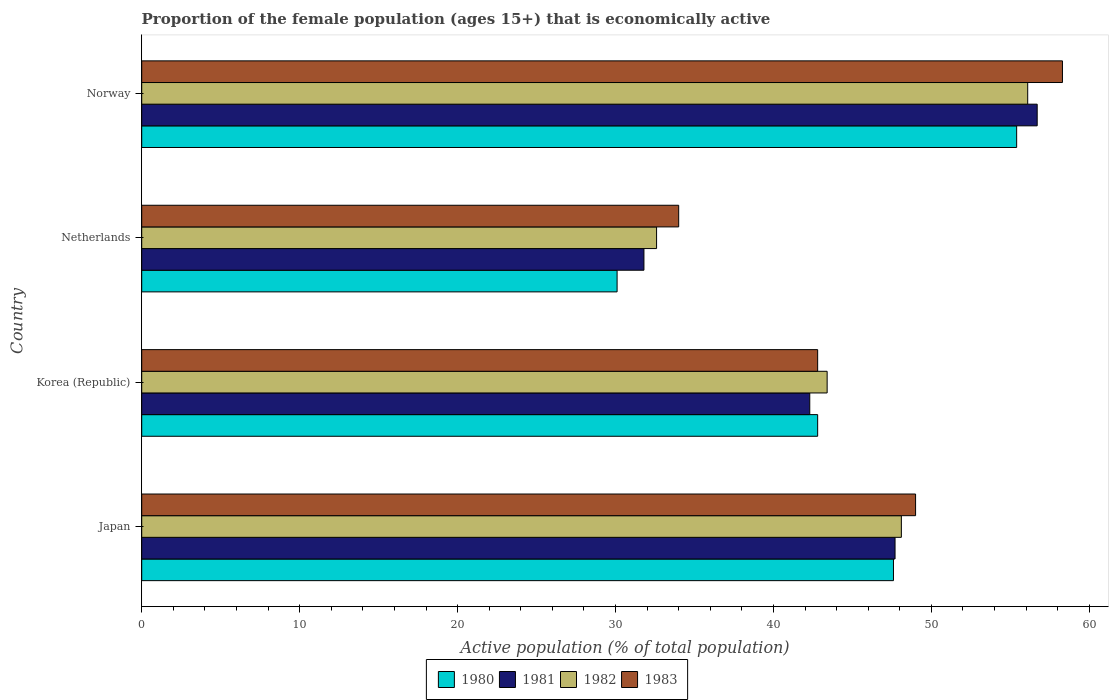How many groups of bars are there?
Provide a short and direct response. 4. How many bars are there on the 3rd tick from the bottom?
Your answer should be compact. 4. What is the label of the 4th group of bars from the top?
Your answer should be very brief. Japan. In how many cases, is the number of bars for a given country not equal to the number of legend labels?
Give a very brief answer. 0. What is the proportion of the female population that is economically active in 1983 in Korea (Republic)?
Your answer should be compact. 42.8. Across all countries, what is the maximum proportion of the female population that is economically active in 1982?
Your response must be concise. 56.1. Across all countries, what is the minimum proportion of the female population that is economically active in 1983?
Provide a succinct answer. 34. In which country was the proportion of the female population that is economically active in 1982 maximum?
Make the answer very short. Norway. What is the total proportion of the female population that is economically active in 1982 in the graph?
Your response must be concise. 180.2. What is the difference between the proportion of the female population that is economically active in 1982 in Netherlands and that in Norway?
Give a very brief answer. -23.5. What is the difference between the proportion of the female population that is economically active in 1982 in Korea (Republic) and the proportion of the female population that is economically active in 1981 in Netherlands?
Ensure brevity in your answer.  11.6. What is the average proportion of the female population that is economically active in 1980 per country?
Offer a terse response. 43.97. What is the difference between the proportion of the female population that is economically active in 1983 and proportion of the female population that is economically active in 1981 in Japan?
Give a very brief answer. 1.3. In how many countries, is the proportion of the female population that is economically active in 1983 greater than 22 %?
Your response must be concise. 4. What is the ratio of the proportion of the female population that is economically active in 1981 in Japan to that in Korea (Republic)?
Your answer should be compact. 1.13. Is the proportion of the female population that is economically active in 1983 in Netherlands less than that in Norway?
Provide a short and direct response. Yes. Is the difference between the proportion of the female population that is economically active in 1983 in Japan and Norway greater than the difference between the proportion of the female population that is economically active in 1981 in Japan and Norway?
Your answer should be very brief. No. What is the difference between the highest and the lowest proportion of the female population that is economically active in 1980?
Provide a succinct answer. 25.3. What does the 1st bar from the top in Norway represents?
Your response must be concise. 1983. What does the 4th bar from the bottom in Japan represents?
Your answer should be very brief. 1983. Is it the case that in every country, the sum of the proportion of the female population that is economically active in 1983 and proportion of the female population that is economically active in 1980 is greater than the proportion of the female population that is economically active in 1981?
Give a very brief answer. Yes. How many bars are there?
Offer a very short reply. 16. Are all the bars in the graph horizontal?
Provide a succinct answer. Yes. What is the difference between two consecutive major ticks on the X-axis?
Offer a very short reply. 10. Does the graph contain any zero values?
Give a very brief answer. No. Does the graph contain grids?
Provide a succinct answer. No. How many legend labels are there?
Offer a terse response. 4. How are the legend labels stacked?
Make the answer very short. Horizontal. What is the title of the graph?
Give a very brief answer. Proportion of the female population (ages 15+) that is economically active. Does "1979" appear as one of the legend labels in the graph?
Your answer should be very brief. No. What is the label or title of the X-axis?
Offer a terse response. Active population (% of total population). What is the Active population (% of total population) of 1980 in Japan?
Keep it short and to the point. 47.6. What is the Active population (% of total population) of 1981 in Japan?
Your answer should be very brief. 47.7. What is the Active population (% of total population) in 1982 in Japan?
Give a very brief answer. 48.1. What is the Active population (% of total population) of 1980 in Korea (Republic)?
Your answer should be very brief. 42.8. What is the Active population (% of total population) of 1981 in Korea (Republic)?
Offer a very short reply. 42.3. What is the Active population (% of total population) of 1982 in Korea (Republic)?
Keep it short and to the point. 43.4. What is the Active population (% of total population) of 1983 in Korea (Republic)?
Your answer should be compact. 42.8. What is the Active population (% of total population) in 1980 in Netherlands?
Keep it short and to the point. 30.1. What is the Active population (% of total population) in 1981 in Netherlands?
Keep it short and to the point. 31.8. What is the Active population (% of total population) in 1982 in Netherlands?
Offer a very short reply. 32.6. What is the Active population (% of total population) in 1983 in Netherlands?
Offer a terse response. 34. What is the Active population (% of total population) in 1980 in Norway?
Your answer should be very brief. 55.4. What is the Active population (% of total population) of 1981 in Norway?
Your response must be concise. 56.7. What is the Active population (% of total population) of 1982 in Norway?
Provide a short and direct response. 56.1. What is the Active population (% of total population) of 1983 in Norway?
Provide a short and direct response. 58.3. Across all countries, what is the maximum Active population (% of total population) in 1980?
Provide a short and direct response. 55.4. Across all countries, what is the maximum Active population (% of total population) of 1981?
Your answer should be very brief. 56.7. Across all countries, what is the maximum Active population (% of total population) in 1982?
Ensure brevity in your answer.  56.1. Across all countries, what is the maximum Active population (% of total population) of 1983?
Give a very brief answer. 58.3. Across all countries, what is the minimum Active population (% of total population) in 1980?
Offer a terse response. 30.1. Across all countries, what is the minimum Active population (% of total population) of 1981?
Your answer should be very brief. 31.8. Across all countries, what is the minimum Active population (% of total population) of 1982?
Keep it short and to the point. 32.6. What is the total Active population (% of total population) of 1980 in the graph?
Offer a very short reply. 175.9. What is the total Active population (% of total population) of 1981 in the graph?
Offer a very short reply. 178.5. What is the total Active population (% of total population) of 1982 in the graph?
Offer a terse response. 180.2. What is the total Active population (% of total population) of 1983 in the graph?
Provide a short and direct response. 184.1. What is the difference between the Active population (% of total population) in 1980 in Japan and that in Korea (Republic)?
Your response must be concise. 4.8. What is the difference between the Active population (% of total population) of 1981 in Japan and that in Korea (Republic)?
Your response must be concise. 5.4. What is the difference between the Active population (% of total population) of 1982 in Japan and that in Korea (Republic)?
Give a very brief answer. 4.7. What is the difference between the Active population (% of total population) in 1980 in Japan and that in Netherlands?
Make the answer very short. 17.5. What is the difference between the Active population (% of total population) of 1983 in Japan and that in Norway?
Make the answer very short. -9.3. What is the difference between the Active population (% of total population) in 1981 in Korea (Republic) and that in Netherlands?
Offer a terse response. 10.5. What is the difference between the Active population (% of total population) of 1982 in Korea (Republic) and that in Netherlands?
Your answer should be compact. 10.8. What is the difference between the Active population (% of total population) of 1981 in Korea (Republic) and that in Norway?
Your response must be concise. -14.4. What is the difference between the Active population (% of total population) in 1983 in Korea (Republic) and that in Norway?
Provide a succinct answer. -15.5. What is the difference between the Active population (% of total population) of 1980 in Netherlands and that in Norway?
Make the answer very short. -25.3. What is the difference between the Active population (% of total population) in 1981 in Netherlands and that in Norway?
Offer a very short reply. -24.9. What is the difference between the Active population (% of total population) of 1982 in Netherlands and that in Norway?
Give a very brief answer. -23.5. What is the difference between the Active population (% of total population) in 1983 in Netherlands and that in Norway?
Provide a short and direct response. -24.3. What is the difference between the Active population (% of total population) of 1980 in Japan and the Active population (% of total population) of 1982 in Korea (Republic)?
Make the answer very short. 4.2. What is the difference between the Active population (% of total population) in 1982 in Japan and the Active population (% of total population) in 1983 in Korea (Republic)?
Offer a terse response. 5.3. What is the difference between the Active population (% of total population) in 1980 in Japan and the Active population (% of total population) in 1982 in Netherlands?
Your answer should be very brief. 15. What is the difference between the Active population (% of total population) of 1980 in Japan and the Active population (% of total population) of 1983 in Netherlands?
Give a very brief answer. 13.6. What is the difference between the Active population (% of total population) of 1981 in Japan and the Active population (% of total population) of 1982 in Netherlands?
Ensure brevity in your answer.  15.1. What is the difference between the Active population (% of total population) of 1980 in Japan and the Active population (% of total population) of 1983 in Norway?
Your answer should be compact. -10.7. What is the difference between the Active population (% of total population) of 1981 in Japan and the Active population (% of total population) of 1982 in Norway?
Offer a terse response. -8.4. What is the difference between the Active population (% of total population) of 1980 in Korea (Republic) and the Active population (% of total population) of 1981 in Netherlands?
Give a very brief answer. 11. What is the difference between the Active population (% of total population) of 1980 in Korea (Republic) and the Active population (% of total population) of 1982 in Netherlands?
Keep it short and to the point. 10.2. What is the difference between the Active population (% of total population) of 1980 in Korea (Republic) and the Active population (% of total population) of 1983 in Netherlands?
Keep it short and to the point. 8.8. What is the difference between the Active population (% of total population) of 1981 in Korea (Republic) and the Active population (% of total population) of 1982 in Netherlands?
Make the answer very short. 9.7. What is the difference between the Active population (% of total population) in 1980 in Korea (Republic) and the Active population (% of total population) in 1981 in Norway?
Offer a terse response. -13.9. What is the difference between the Active population (% of total population) of 1980 in Korea (Republic) and the Active population (% of total population) of 1982 in Norway?
Your response must be concise. -13.3. What is the difference between the Active population (% of total population) in 1980 in Korea (Republic) and the Active population (% of total population) in 1983 in Norway?
Provide a succinct answer. -15.5. What is the difference between the Active population (% of total population) of 1981 in Korea (Republic) and the Active population (% of total population) of 1983 in Norway?
Offer a very short reply. -16. What is the difference between the Active population (% of total population) of 1982 in Korea (Republic) and the Active population (% of total population) of 1983 in Norway?
Ensure brevity in your answer.  -14.9. What is the difference between the Active population (% of total population) in 1980 in Netherlands and the Active population (% of total population) in 1981 in Norway?
Your response must be concise. -26.6. What is the difference between the Active population (% of total population) in 1980 in Netherlands and the Active population (% of total population) in 1983 in Norway?
Offer a terse response. -28.2. What is the difference between the Active population (% of total population) of 1981 in Netherlands and the Active population (% of total population) of 1982 in Norway?
Ensure brevity in your answer.  -24.3. What is the difference between the Active population (% of total population) in 1981 in Netherlands and the Active population (% of total population) in 1983 in Norway?
Offer a very short reply. -26.5. What is the difference between the Active population (% of total population) of 1982 in Netherlands and the Active population (% of total population) of 1983 in Norway?
Give a very brief answer. -25.7. What is the average Active population (% of total population) of 1980 per country?
Your answer should be very brief. 43.98. What is the average Active population (% of total population) in 1981 per country?
Give a very brief answer. 44.62. What is the average Active population (% of total population) in 1982 per country?
Offer a terse response. 45.05. What is the average Active population (% of total population) of 1983 per country?
Give a very brief answer. 46.02. What is the difference between the Active population (% of total population) in 1980 and Active population (% of total population) in 1982 in Japan?
Offer a very short reply. -0.5. What is the difference between the Active population (% of total population) in 1981 and Active population (% of total population) in 1982 in Japan?
Your answer should be very brief. -0.4. What is the difference between the Active population (% of total population) of 1982 and Active population (% of total population) of 1983 in Japan?
Provide a short and direct response. -0.9. What is the difference between the Active population (% of total population) in 1980 and Active population (% of total population) in 1981 in Korea (Republic)?
Provide a succinct answer. 0.5. What is the difference between the Active population (% of total population) in 1981 and Active population (% of total population) in 1983 in Korea (Republic)?
Ensure brevity in your answer.  -0.5. What is the difference between the Active population (% of total population) of 1980 and Active population (% of total population) of 1982 in Netherlands?
Your answer should be compact. -2.5. What is the difference between the Active population (% of total population) of 1980 and Active population (% of total population) of 1983 in Netherlands?
Your answer should be compact. -3.9. What is the difference between the Active population (% of total population) in 1981 and Active population (% of total population) in 1982 in Netherlands?
Your response must be concise. -0.8. What is the difference between the Active population (% of total population) of 1981 and Active population (% of total population) of 1983 in Netherlands?
Give a very brief answer. -2.2. What is the difference between the Active population (% of total population) of 1982 and Active population (% of total population) of 1983 in Netherlands?
Offer a terse response. -1.4. What is the difference between the Active population (% of total population) of 1981 and Active population (% of total population) of 1982 in Norway?
Give a very brief answer. 0.6. What is the difference between the Active population (% of total population) in 1981 and Active population (% of total population) in 1983 in Norway?
Provide a succinct answer. -1.6. What is the ratio of the Active population (% of total population) in 1980 in Japan to that in Korea (Republic)?
Your answer should be very brief. 1.11. What is the ratio of the Active population (% of total population) of 1981 in Japan to that in Korea (Republic)?
Give a very brief answer. 1.13. What is the ratio of the Active population (% of total population) of 1982 in Japan to that in Korea (Republic)?
Provide a succinct answer. 1.11. What is the ratio of the Active population (% of total population) of 1983 in Japan to that in Korea (Republic)?
Your response must be concise. 1.14. What is the ratio of the Active population (% of total population) of 1980 in Japan to that in Netherlands?
Your answer should be very brief. 1.58. What is the ratio of the Active population (% of total population) of 1981 in Japan to that in Netherlands?
Give a very brief answer. 1.5. What is the ratio of the Active population (% of total population) of 1982 in Japan to that in Netherlands?
Provide a succinct answer. 1.48. What is the ratio of the Active population (% of total population) of 1983 in Japan to that in Netherlands?
Give a very brief answer. 1.44. What is the ratio of the Active population (% of total population) of 1980 in Japan to that in Norway?
Your answer should be very brief. 0.86. What is the ratio of the Active population (% of total population) of 1981 in Japan to that in Norway?
Make the answer very short. 0.84. What is the ratio of the Active population (% of total population) of 1982 in Japan to that in Norway?
Provide a succinct answer. 0.86. What is the ratio of the Active population (% of total population) of 1983 in Japan to that in Norway?
Offer a very short reply. 0.84. What is the ratio of the Active population (% of total population) of 1980 in Korea (Republic) to that in Netherlands?
Your response must be concise. 1.42. What is the ratio of the Active population (% of total population) in 1981 in Korea (Republic) to that in Netherlands?
Make the answer very short. 1.33. What is the ratio of the Active population (% of total population) of 1982 in Korea (Republic) to that in Netherlands?
Make the answer very short. 1.33. What is the ratio of the Active population (% of total population) in 1983 in Korea (Republic) to that in Netherlands?
Your answer should be compact. 1.26. What is the ratio of the Active population (% of total population) of 1980 in Korea (Republic) to that in Norway?
Your response must be concise. 0.77. What is the ratio of the Active population (% of total population) in 1981 in Korea (Republic) to that in Norway?
Your answer should be very brief. 0.75. What is the ratio of the Active population (% of total population) of 1982 in Korea (Republic) to that in Norway?
Your answer should be very brief. 0.77. What is the ratio of the Active population (% of total population) in 1983 in Korea (Republic) to that in Norway?
Give a very brief answer. 0.73. What is the ratio of the Active population (% of total population) in 1980 in Netherlands to that in Norway?
Ensure brevity in your answer.  0.54. What is the ratio of the Active population (% of total population) of 1981 in Netherlands to that in Norway?
Offer a terse response. 0.56. What is the ratio of the Active population (% of total population) in 1982 in Netherlands to that in Norway?
Give a very brief answer. 0.58. What is the ratio of the Active population (% of total population) of 1983 in Netherlands to that in Norway?
Your answer should be very brief. 0.58. What is the difference between the highest and the second highest Active population (% of total population) in 1980?
Keep it short and to the point. 7.8. What is the difference between the highest and the second highest Active population (% of total population) of 1981?
Give a very brief answer. 9. What is the difference between the highest and the lowest Active population (% of total population) of 1980?
Your answer should be very brief. 25.3. What is the difference between the highest and the lowest Active population (% of total population) of 1981?
Provide a succinct answer. 24.9. What is the difference between the highest and the lowest Active population (% of total population) of 1982?
Make the answer very short. 23.5. What is the difference between the highest and the lowest Active population (% of total population) in 1983?
Give a very brief answer. 24.3. 